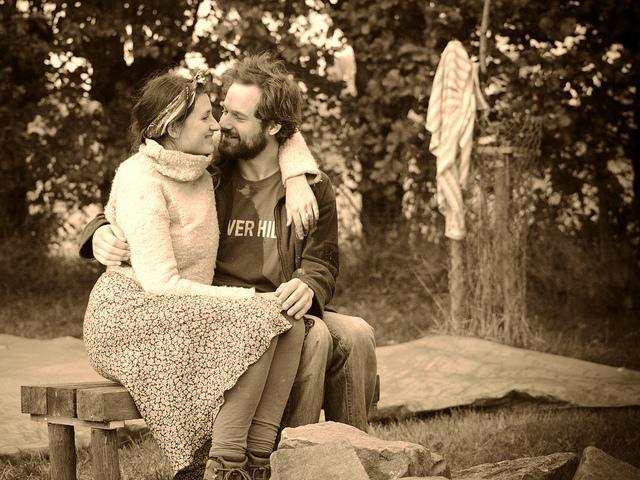How many people can be seen?
Give a very brief answer. 2. How many birds have their wings spread?
Give a very brief answer. 0. 